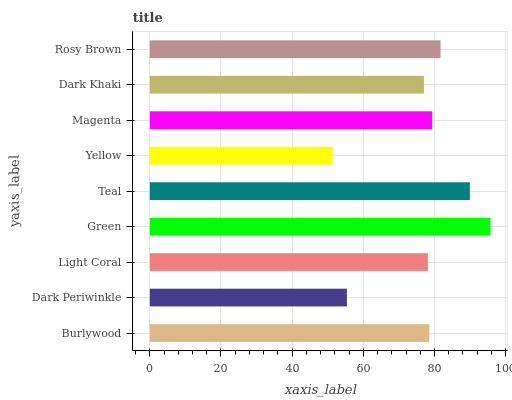Is Yellow the minimum?
Answer yes or no. Yes. Is Green the maximum?
Answer yes or no. Yes. Is Dark Periwinkle the minimum?
Answer yes or no. No. Is Dark Periwinkle the maximum?
Answer yes or no. No. Is Burlywood greater than Dark Periwinkle?
Answer yes or no. Yes. Is Dark Periwinkle less than Burlywood?
Answer yes or no. Yes. Is Dark Periwinkle greater than Burlywood?
Answer yes or no. No. Is Burlywood less than Dark Periwinkle?
Answer yes or no. No. Is Burlywood the high median?
Answer yes or no. Yes. Is Burlywood the low median?
Answer yes or no. Yes. Is Dark Periwinkle the high median?
Answer yes or no. No. Is Yellow the low median?
Answer yes or no. No. 